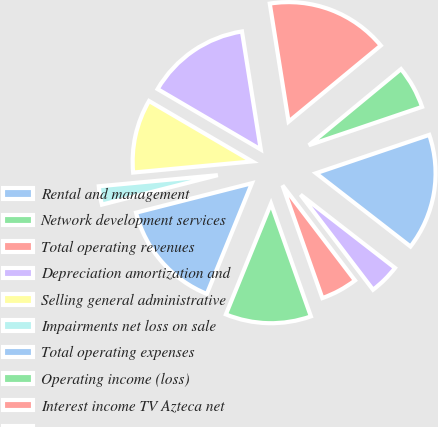Convert chart to OTSL. <chart><loc_0><loc_0><loc_500><loc_500><pie_chart><fcel>Rental and management<fcel>Network development services<fcel>Total operating revenues<fcel>Depreciation amortization and<fcel>Selling general administrative<fcel>Impairments net loss on sale<fcel>Total operating expenses<fcel>Operating income (loss)<fcel>Interest income TV Azteca net<fcel>Interest income<nl><fcel>15.7%<fcel>5.79%<fcel>16.53%<fcel>14.05%<fcel>9.92%<fcel>2.48%<fcel>14.88%<fcel>11.57%<fcel>4.96%<fcel>4.13%<nl></chart> 